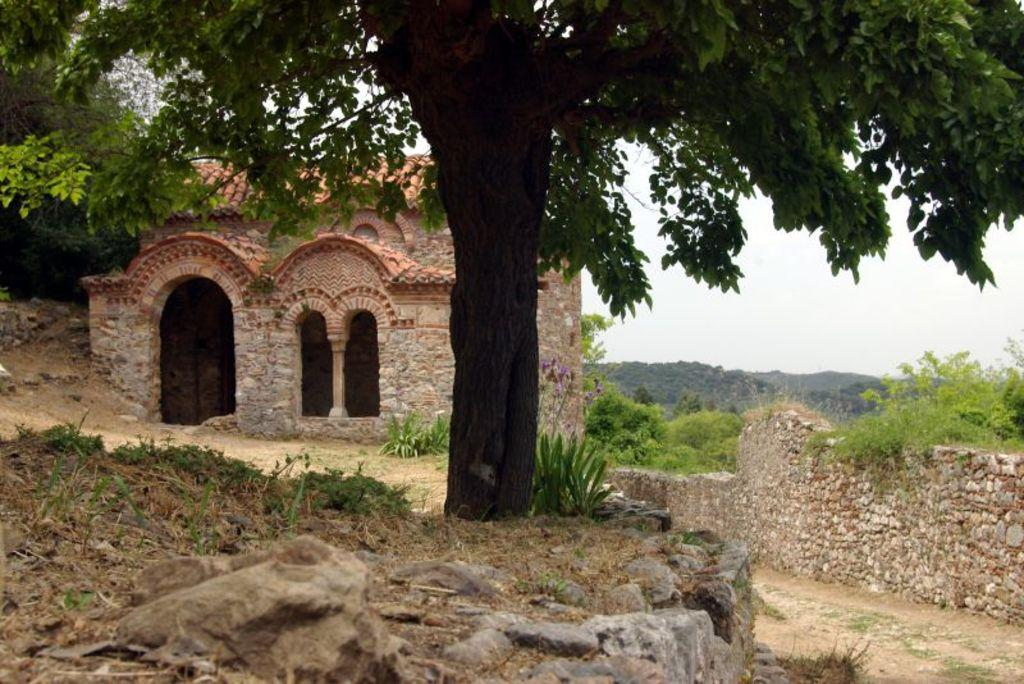What is located in the foreground of the image? In the foreground of the image, there is a rock, grass, a tree, and a plant. Can you describe the vegetation in the foreground? The vegetation in the foreground includes grass and a tree. What structures can be seen in the background of the image? In the background of the image, there is a stone wall, trees, a building, and an arch. What part of the natural environment is visible in the image? The sky is visible in the background of the image. What type of sound can be heard coming from the airport in the image? There is no airport present in the image, so it is not possible to determine what, if any, sounds might be heard. How does the behavior of the plant in the foreground change throughout the day? The image is a still photograph, so it does not show any changes in the behavior of the plant over time. 